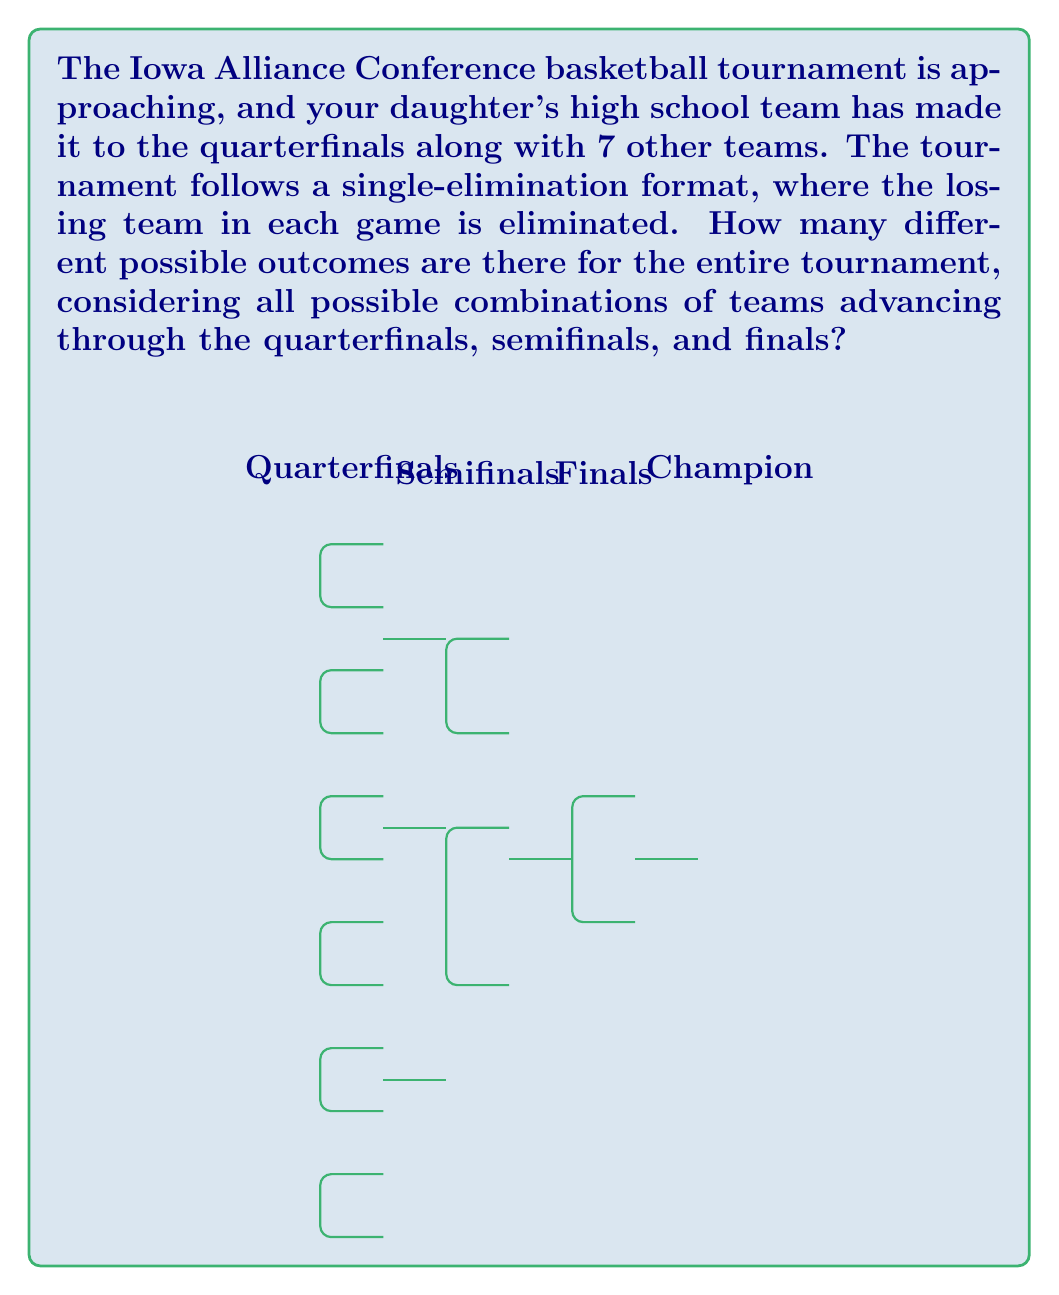What is the answer to this math problem? Let's approach this step-by-step:

1) First, we need to understand that in a single-elimination tournament, each game has 2 possible outcomes (either team can win).

2) Let's break down the tournament stages:
   - Quarterfinals: 4 games
   - Semifinals: 2 games
   - Finals: 1 game

3) For the quarterfinals:
   - Each game has 2 possible outcomes
   - There are 4 games
   - Total possibilities for quarterfinals: $2^4 = 16$

4) For the semifinals:
   - 2 games, each with 2 possible outcomes
   - Total possibilities for semifinals: $2^2 = 4$

5) For the finals:
   - 1 game with 2 possible outcomes
   - Total possibilities for finals: $2^1 = 2$

6) To find the total number of possible outcomes for the entire tournament, we multiply the possibilities at each stage:

   $$ \text{Total outcomes} = 16 \times 4 \times 2 = 128 $$

7) We can also express this as:

   $$ \text{Total outcomes} = 2^4 \times 2^2 \times 2^1 = 2^7 = 128 $$

This means there are 128 different possible ways the tournament could unfold, considering all possible combinations of teams advancing through each round.
Answer: 128 